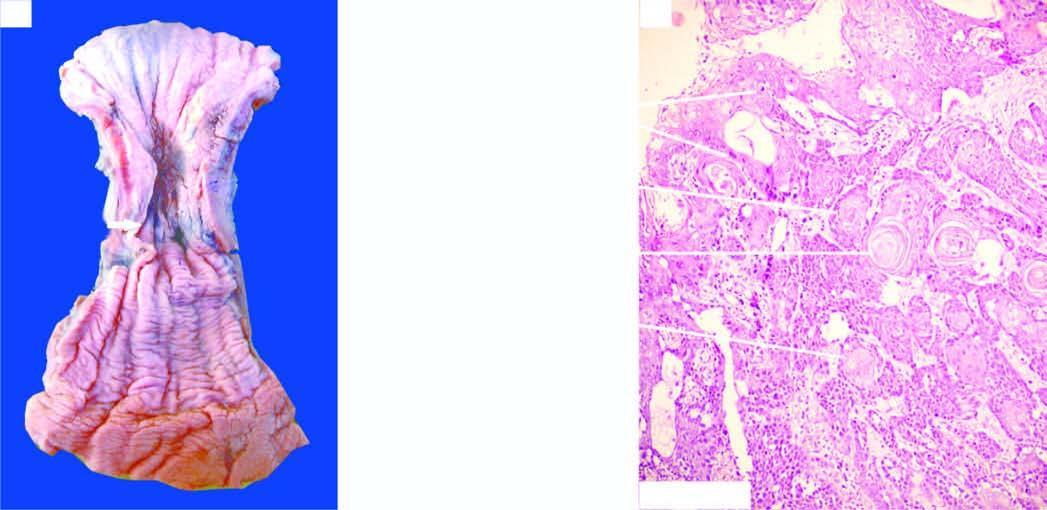s sectioned surface of the lung a concentric circumferential thickening in the middle causing narrowing of the lumen?
Answer the question using a single word or phrase. No 